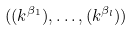Convert formula to latex. <formula><loc_0><loc_0><loc_500><loc_500>( ( k ^ { \beta _ { 1 } } ) , \dots , ( k ^ { \beta _ { l } } ) )</formula> 